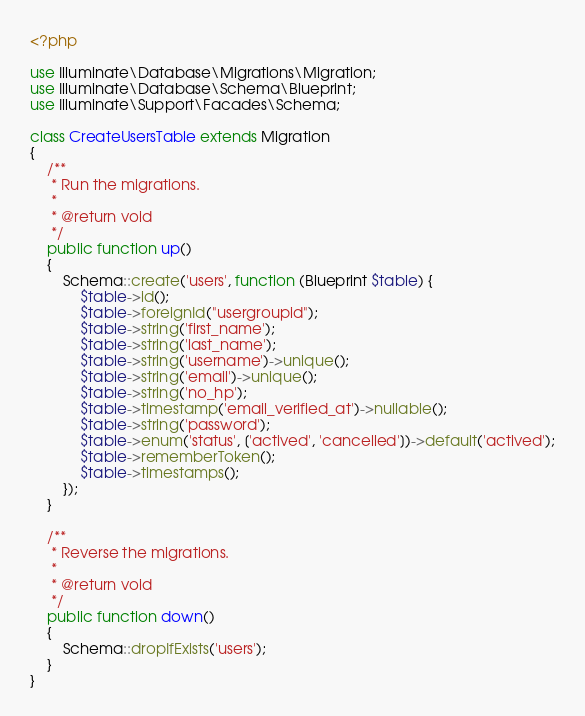<code> <loc_0><loc_0><loc_500><loc_500><_PHP_><?php

use Illuminate\Database\Migrations\Migration;
use Illuminate\Database\Schema\Blueprint;
use Illuminate\Support\Facades\Schema;

class CreateUsersTable extends Migration
{
    /**
     * Run the migrations.
     *
     * @return void
     */
    public function up()
    {
        Schema::create('users', function (Blueprint $table) {
            $table->id();
            $table->foreignId("usergroupid");
            $table->string('first_name');
            $table->string('last_name');
            $table->string('username')->unique();
            $table->string('email')->unique();
            $table->string('no_hp');
            $table->timestamp('email_verified_at')->nullable();
            $table->string('password');
            $table->enum('status', ['actived', 'cancelled'])->default('actived');
            $table->rememberToken();
            $table->timestamps();
        });
    }

    /**
     * Reverse the migrations.
     *
     * @return void
     */
    public function down()
    {
        Schema::dropIfExists('users');
    }
}
</code> 